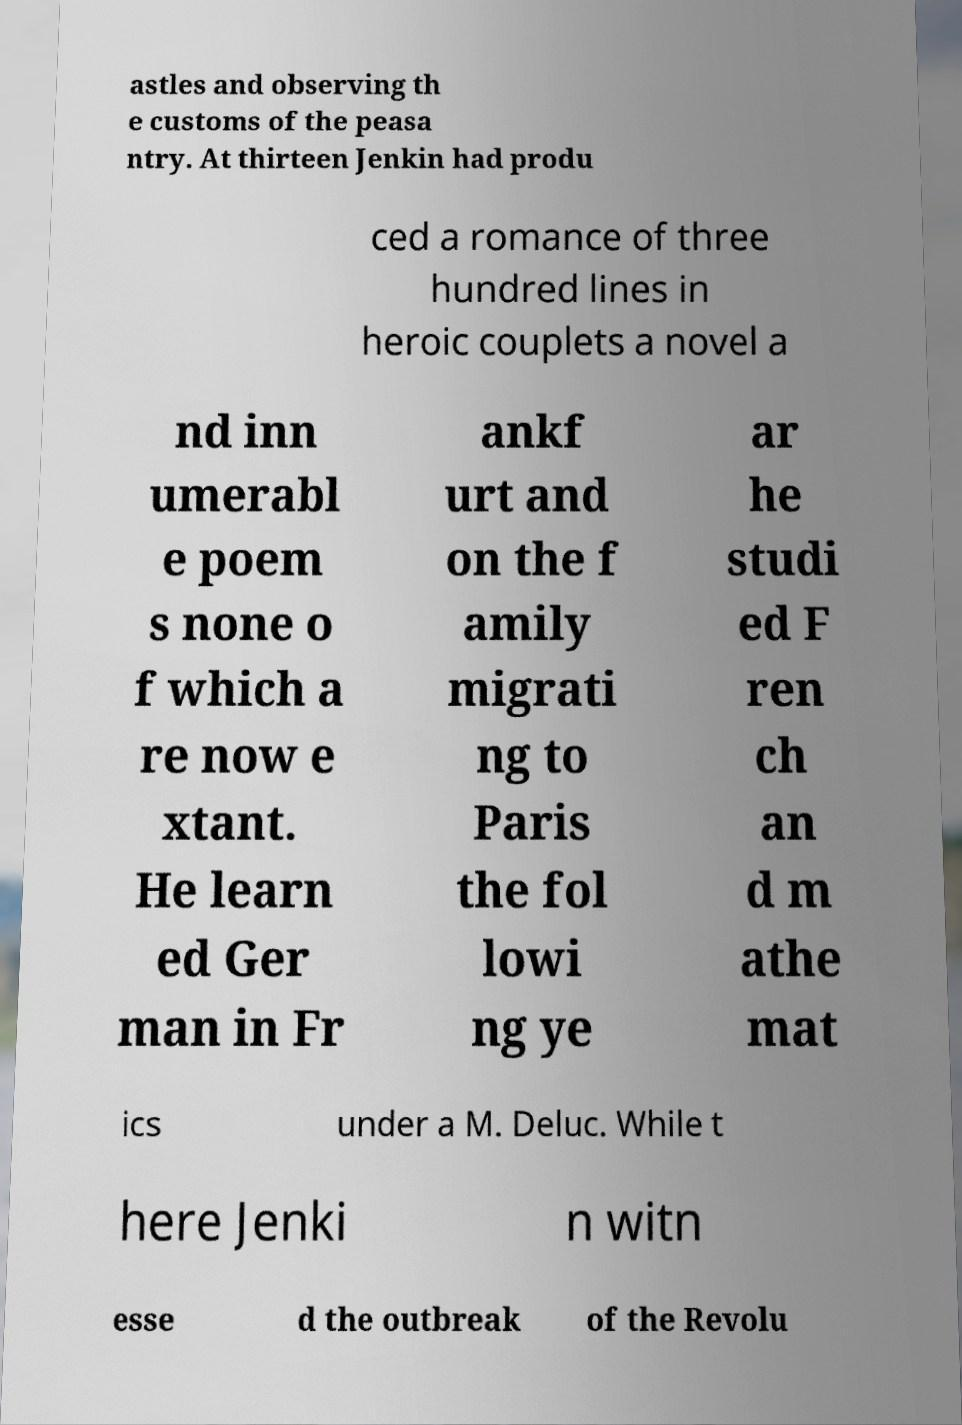What messages or text are displayed in this image? I need them in a readable, typed format. astles and observing th e customs of the peasa ntry. At thirteen Jenkin had produ ced a romance of three hundred lines in heroic couplets a novel a nd inn umerabl e poem s none o f which a re now e xtant. He learn ed Ger man in Fr ankf urt and on the f amily migrati ng to Paris the fol lowi ng ye ar he studi ed F ren ch an d m athe mat ics under a M. Deluc. While t here Jenki n witn esse d the outbreak of the Revolu 